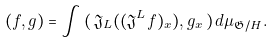Convert formula to latex. <formula><loc_0><loc_0><loc_500><loc_500>( f , g ) = \int \, ( \, \mathfrak { J } _ { L } ( ( \mathfrak { J } ^ { L } f ) _ { x } ) , g _ { x } \, ) \, d \mu _ { \mathfrak { G } / H } .</formula> 